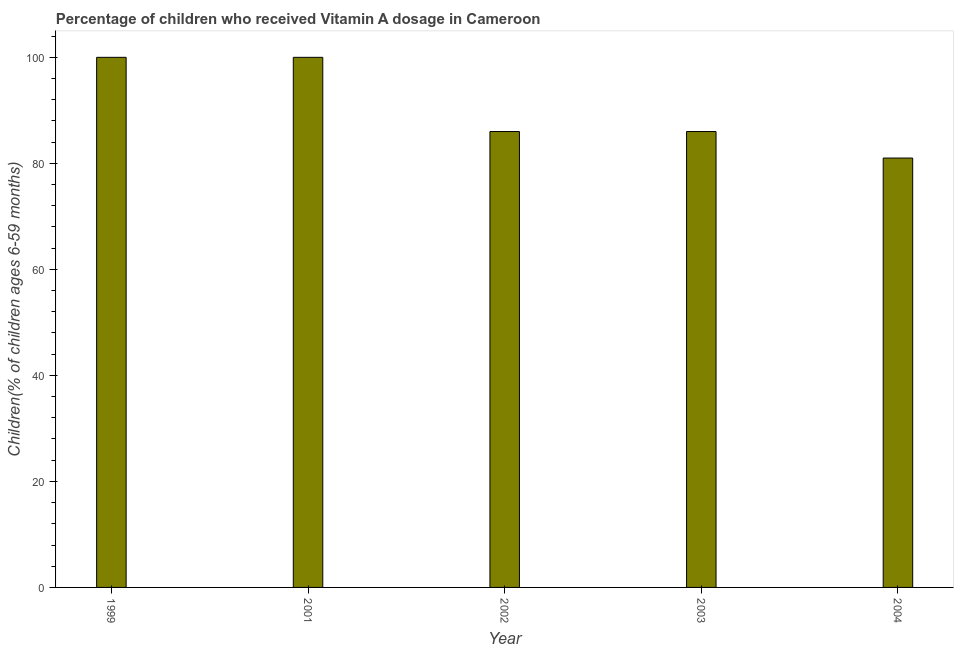Does the graph contain any zero values?
Provide a succinct answer. No. Does the graph contain grids?
Provide a short and direct response. No. What is the title of the graph?
Provide a succinct answer. Percentage of children who received Vitamin A dosage in Cameroon. What is the label or title of the Y-axis?
Provide a succinct answer. Children(% of children ages 6-59 months). Across all years, what is the maximum vitamin a supplementation coverage rate?
Provide a succinct answer. 100. In which year was the vitamin a supplementation coverage rate maximum?
Make the answer very short. 1999. What is the sum of the vitamin a supplementation coverage rate?
Your response must be concise. 453. What is the difference between the vitamin a supplementation coverage rate in 2002 and 2004?
Keep it short and to the point. 5. What is the average vitamin a supplementation coverage rate per year?
Your answer should be very brief. 90.6. Do a majority of the years between 2002 and 2004 (inclusive) have vitamin a supplementation coverage rate greater than 16 %?
Offer a terse response. Yes. What is the ratio of the vitamin a supplementation coverage rate in 2001 to that in 2003?
Your answer should be compact. 1.16. Is the vitamin a supplementation coverage rate in 1999 less than that in 2003?
Your response must be concise. No. What is the difference between the highest and the second highest vitamin a supplementation coverage rate?
Ensure brevity in your answer.  0. Is the sum of the vitamin a supplementation coverage rate in 2003 and 2004 greater than the maximum vitamin a supplementation coverage rate across all years?
Offer a terse response. Yes. How many bars are there?
Offer a terse response. 5. What is the difference between two consecutive major ticks on the Y-axis?
Give a very brief answer. 20. What is the Children(% of children ages 6-59 months) in 2002?
Ensure brevity in your answer.  86. What is the Children(% of children ages 6-59 months) in 2004?
Give a very brief answer. 81. What is the difference between the Children(% of children ages 6-59 months) in 1999 and 2001?
Provide a short and direct response. 0. What is the difference between the Children(% of children ages 6-59 months) in 1999 and 2002?
Give a very brief answer. 14. What is the difference between the Children(% of children ages 6-59 months) in 1999 and 2003?
Provide a succinct answer. 14. What is the difference between the Children(% of children ages 6-59 months) in 1999 and 2004?
Ensure brevity in your answer.  19. What is the ratio of the Children(% of children ages 6-59 months) in 1999 to that in 2002?
Your response must be concise. 1.16. What is the ratio of the Children(% of children ages 6-59 months) in 1999 to that in 2003?
Offer a terse response. 1.16. What is the ratio of the Children(% of children ages 6-59 months) in 1999 to that in 2004?
Provide a succinct answer. 1.24. What is the ratio of the Children(% of children ages 6-59 months) in 2001 to that in 2002?
Give a very brief answer. 1.16. What is the ratio of the Children(% of children ages 6-59 months) in 2001 to that in 2003?
Make the answer very short. 1.16. What is the ratio of the Children(% of children ages 6-59 months) in 2001 to that in 2004?
Offer a very short reply. 1.24. What is the ratio of the Children(% of children ages 6-59 months) in 2002 to that in 2003?
Make the answer very short. 1. What is the ratio of the Children(% of children ages 6-59 months) in 2002 to that in 2004?
Give a very brief answer. 1.06. What is the ratio of the Children(% of children ages 6-59 months) in 2003 to that in 2004?
Your answer should be very brief. 1.06. 